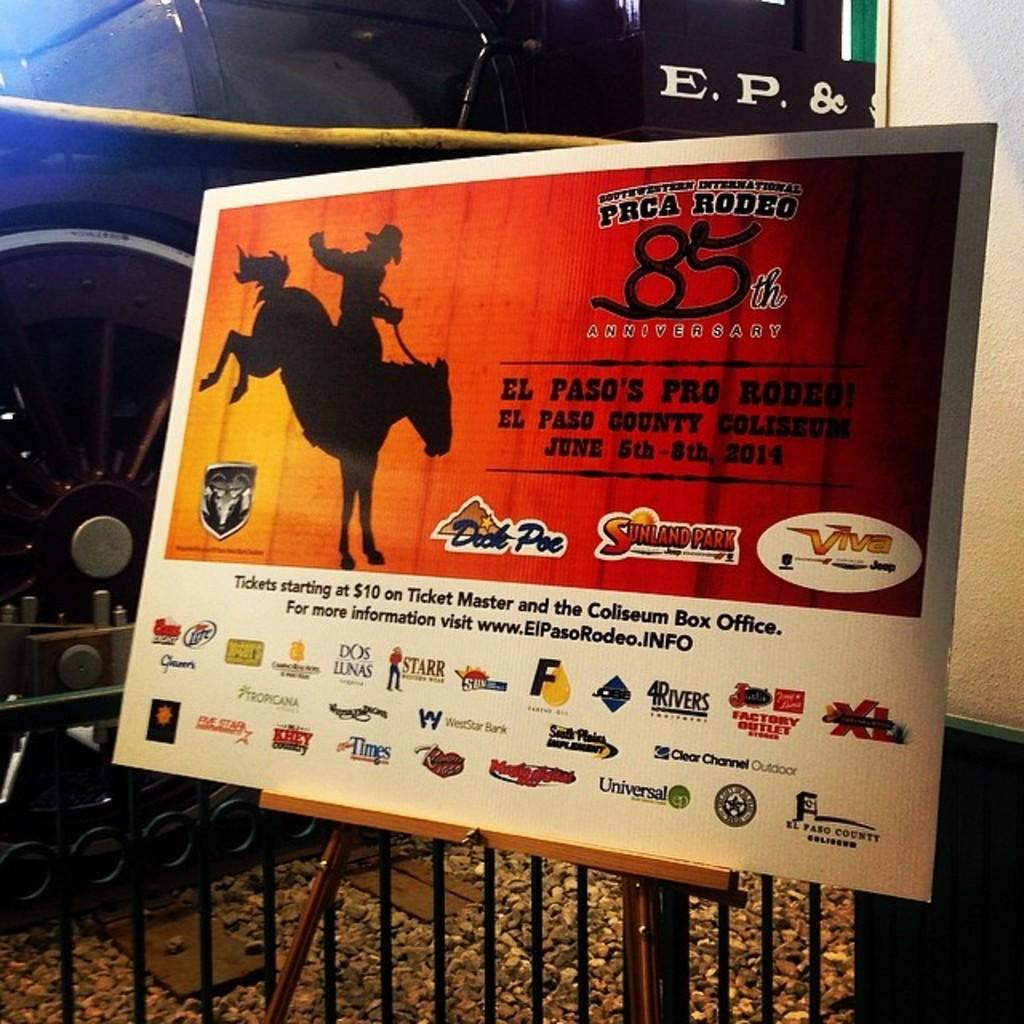Provide a one-sentence caption for the provided image. PRCA Rodeo billboard with sponsors at the bottom. 